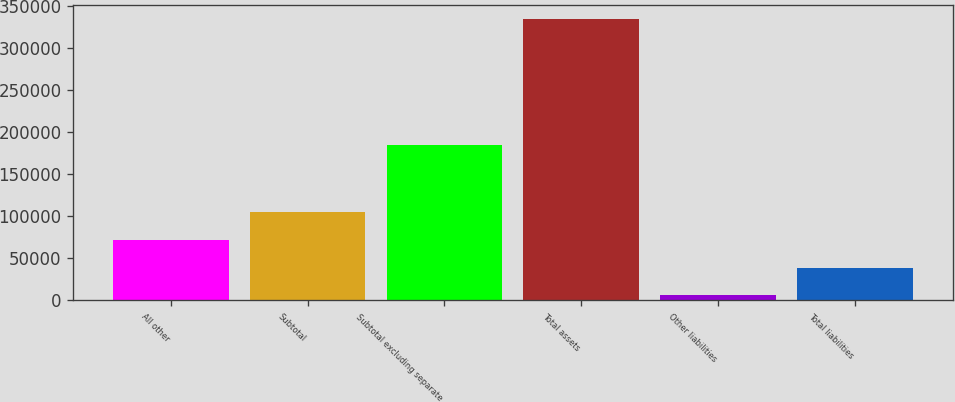<chart> <loc_0><loc_0><loc_500><loc_500><bar_chart><fcel>All other<fcel>Subtotal<fcel>Subtotal excluding separate<fcel>Total assets<fcel>Other liabilities<fcel>Total liabilities<nl><fcel>71843.8<fcel>104685<fcel>184943<fcel>334571<fcel>6162<fcel>39002.9<nl></chart> 